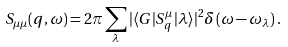<formula> <loc_0><loc_0><loc_500><loc_500>S _ { \mu \mu } ( q , \omega ) = 2 \pi \sum _ { \lambda } | \langle G | S _ { q } ^ { \mu } | \lambda \rangle | ^ { 2 } \delta \left ( \omega - \omega _ { \lambda } \right ) .</formula> 